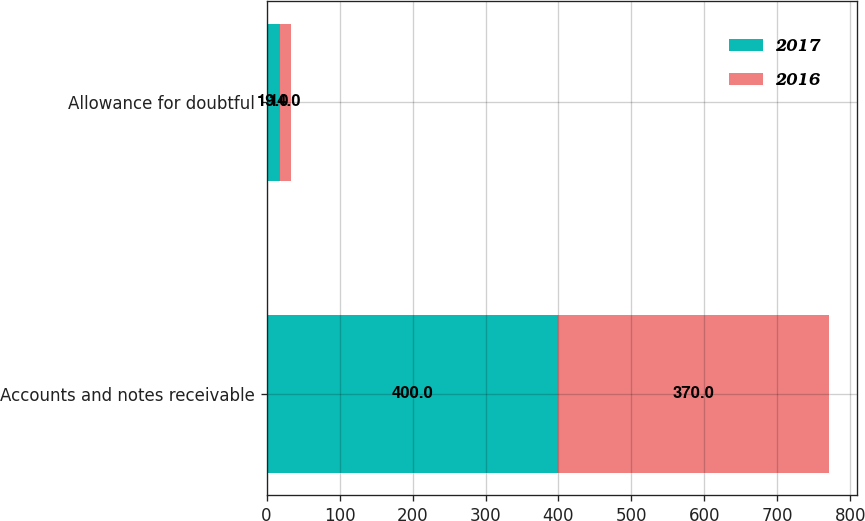Convert chart to OTSL. <chart><loc_0><loc_0><loc_500><loc_500><stacked_bar_chart><ecel><fcel>Accounts and notes receivable<fcel>Allowance for doubtful<nl><fcel>2017<fcel>400<fcel>19<nl><fcel>2016<fcel>370<fcel>14<nl></chart> 